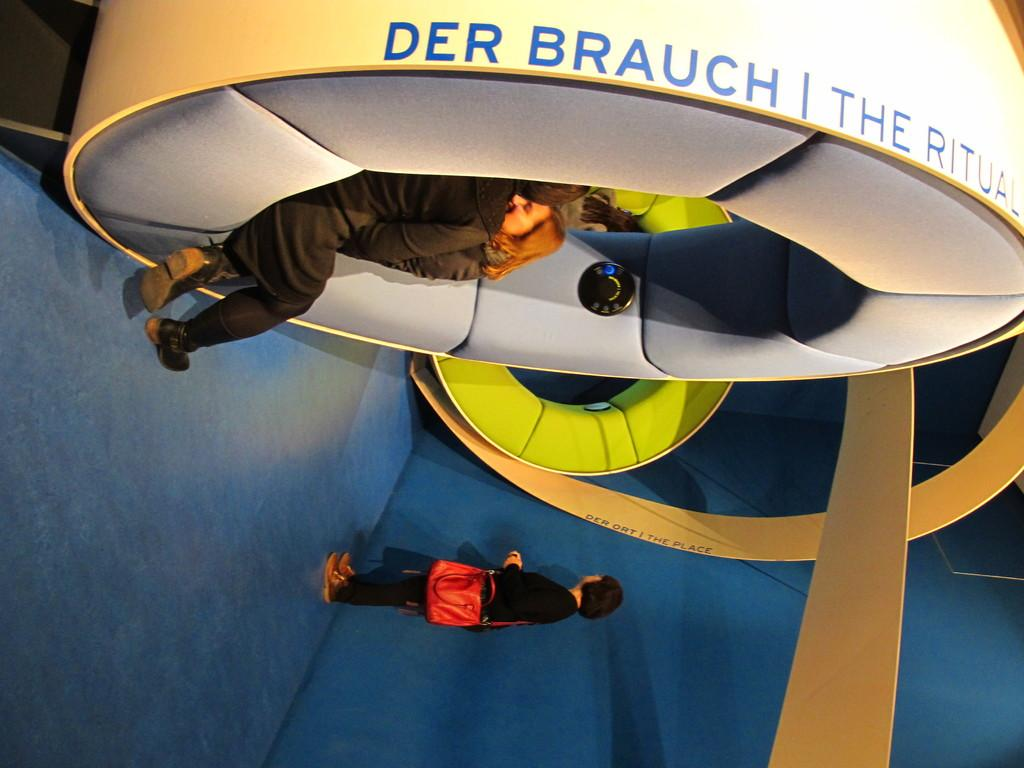What are the two persons in the image doing? The two persons are sitting on an object in the image. Can you describe the position of the third person in the image? There is a person standing nearby in the image. What is the standing person wearing? The standing person is wearing a bag. What color is the floor in the image? The floor in the image is blue. What type of sheet is being used to cover the object the two persons are sitting on? There is no sheet present in the image; the object is not covered. What degree of difficulty is the person standing nearby experiencing in the image? There is no indication of difficulty or degree in the image; the person is simply standing nearby. 